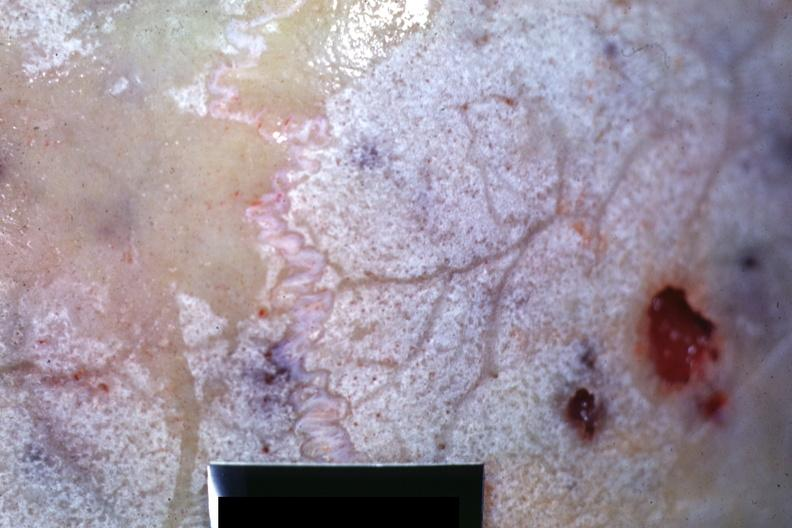s multiple myeloma present?
Answer the question using a single word or phrase. Yes 